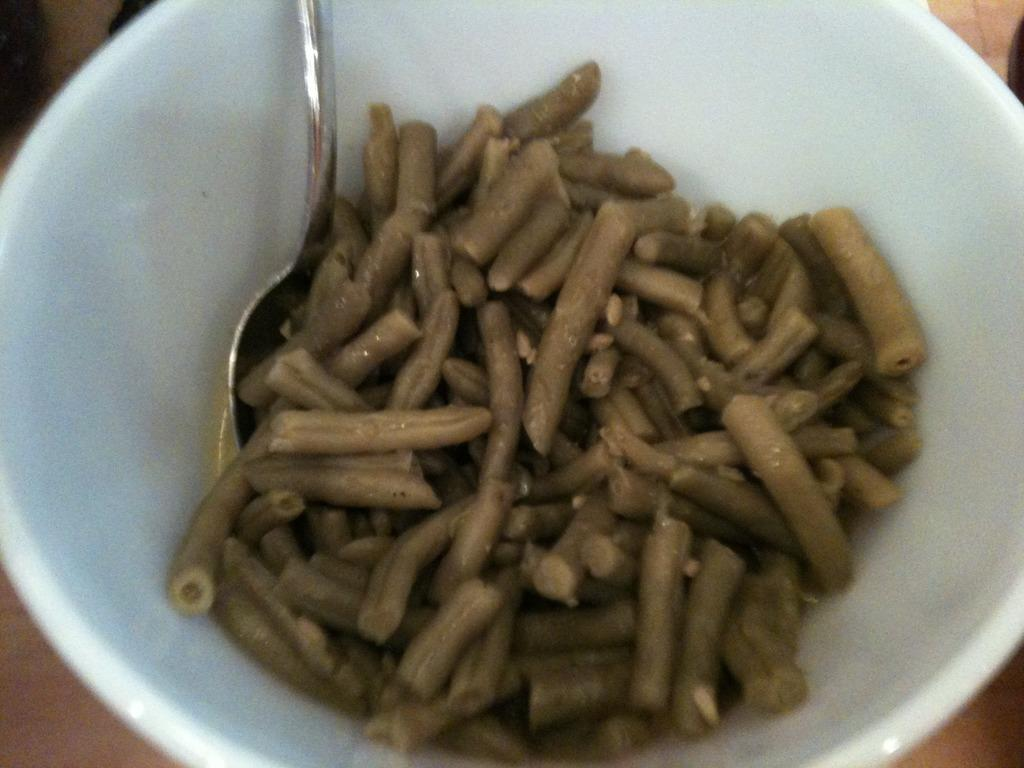What object is present on the table in the image? There is a bowl on the table in the image. What is inside the bowl? The bowl contains stones and beans. Can you describe the contents of the bowl in more detail? The bowl contains both stones and beans. Is there a ghost visible in the image? No, there is no ghost present in the image. Can you see a boy playing with the stones and beans in the image? No, there is no boy present in the image. 